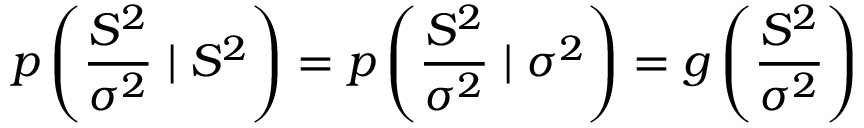Convert formula to latex. <formula><loc_0><loc_0><loc_500><loc_500>p \left ( { \frac { S ^ { 2 } } { \sigma ^ { 2 } } } | S ^ { 2 } \right ) = p \left ( { \frac { S ^ { 2 } } { \sigma ^ { 2 } } } | \sigma ^ { 2 } \right ) = g \left ( { \frac { S ^ { 2 } } { \sigma ^ { 2 } } } \right )</formula> 